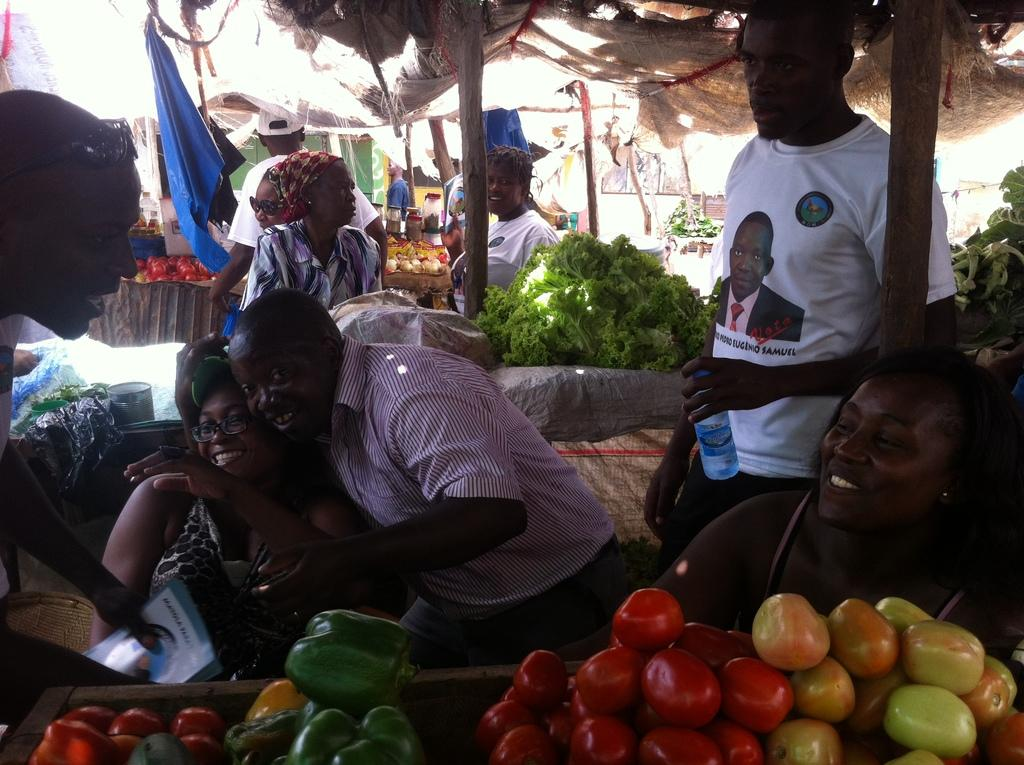What type of stalls can be seen in the image? There are vegetable stalls in the image. Can you describe the people in the image? There are people in the image. What material are the poles made of in the image? The poles in the image are made of wood. What is providing shelter in the image? There is cloth for shelter at the top of the image. Are there any cobwebs visible on the vegetable stalls in the image? There is no mention of cobwebs in the provided facts, so we cannot determine if any are present in the image. 